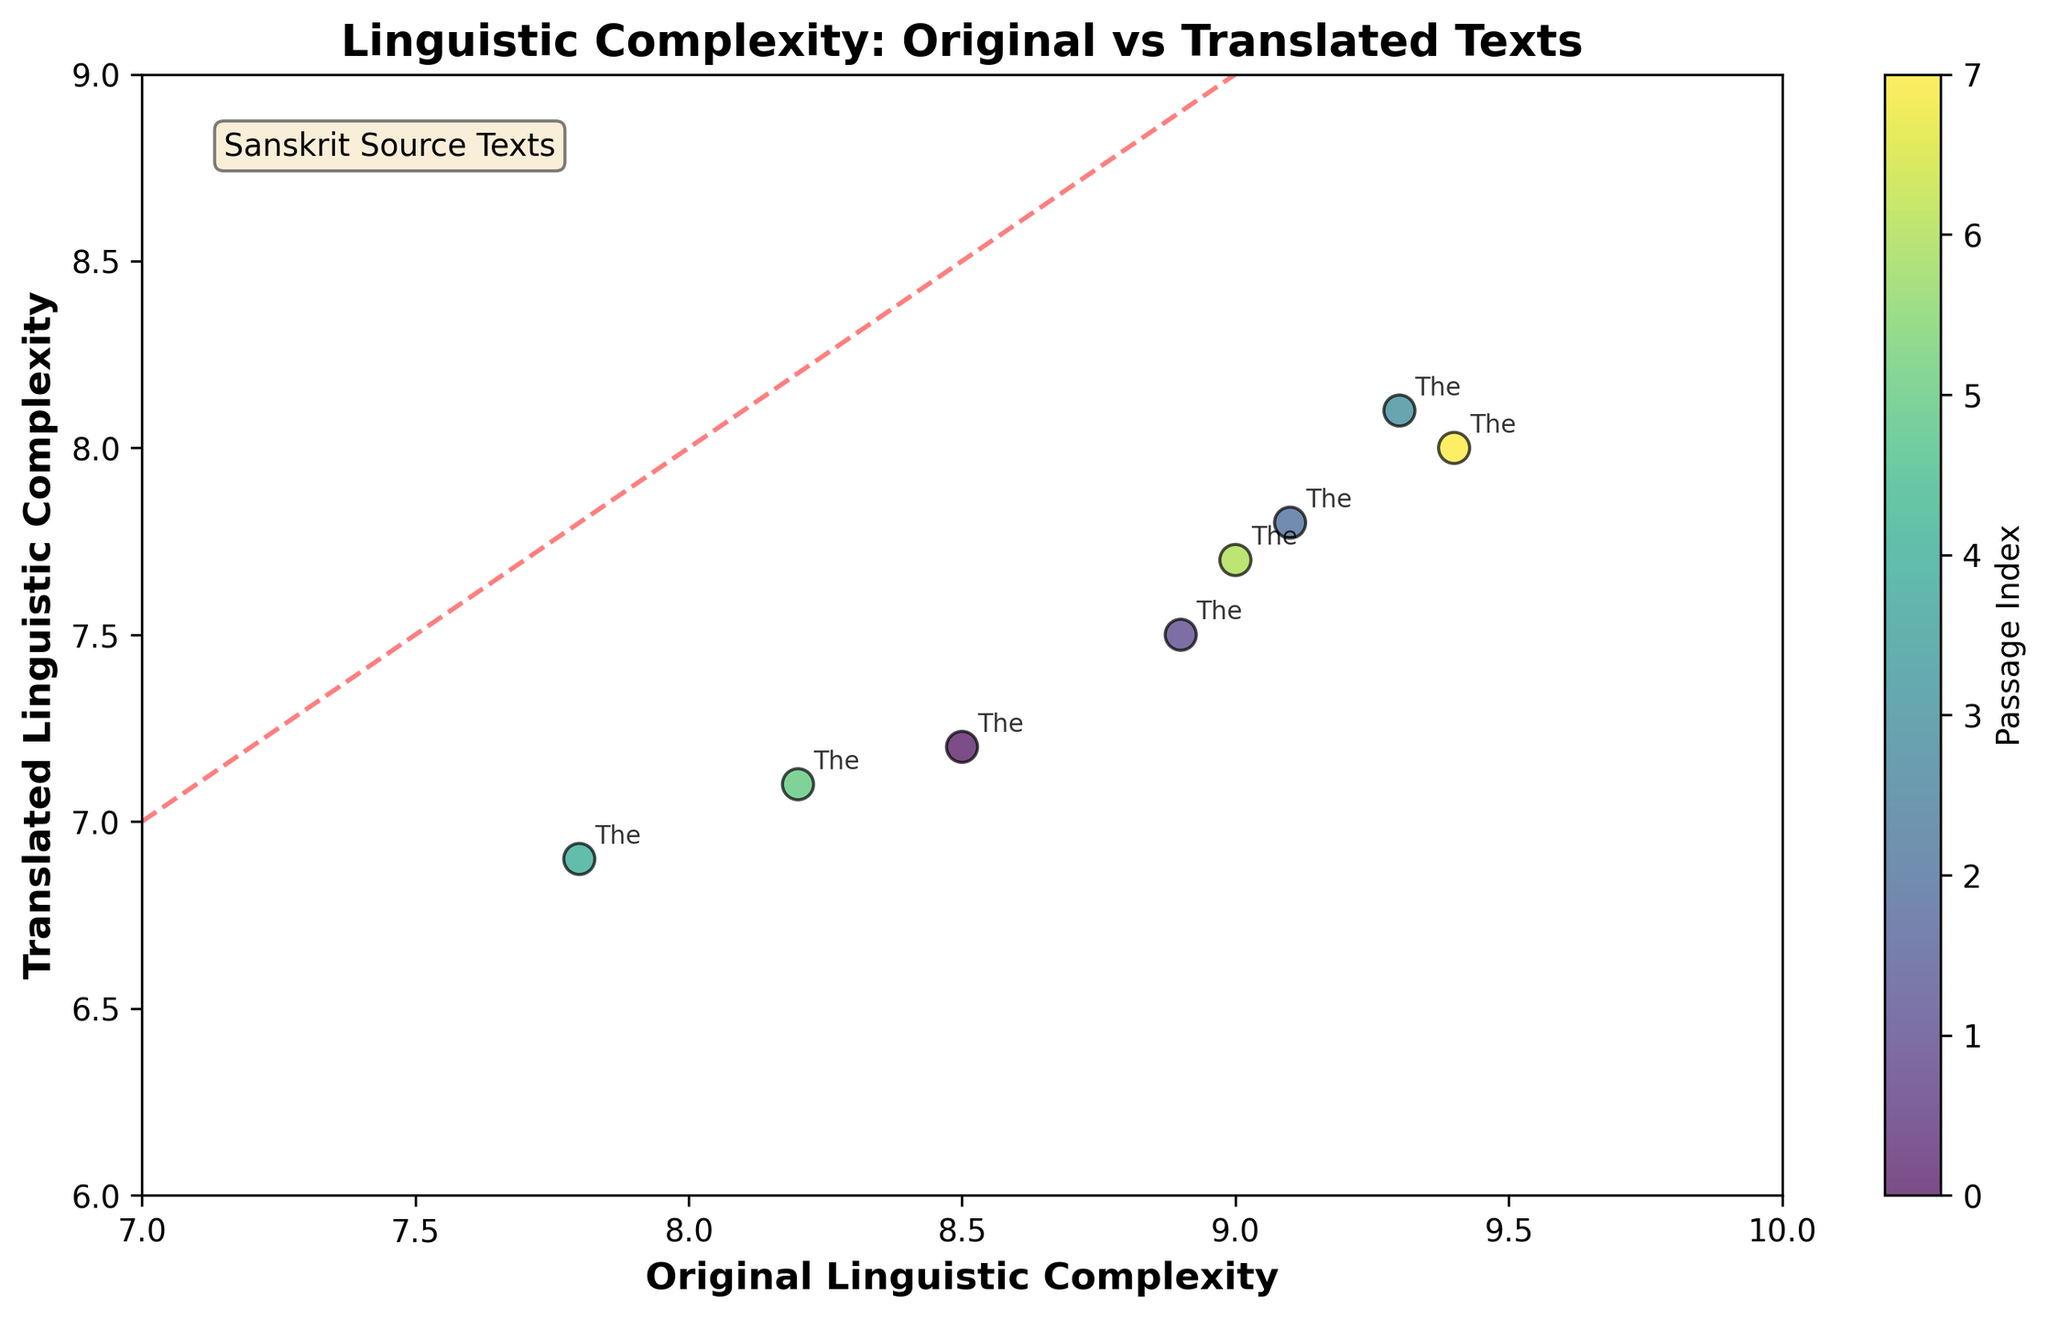What is the title of the plot? The title is located at the top of the plot and reads "Linguistic Complexity: Original vs Translated Texts".
Answer: Linguistic Complexity: Original vs Translated Texts What does the x-axis represent? The label on the x-axis shows "Original Linguistic Complexity", indicating it displays linguistic complexity scores of the original texts.
Answer: Original Linguistic Complexity What feature is represented by the colors of the scatter plot? The colorbar labeled "Passage Index" indicates that different colors correspond to different passages from the texts.
Answer: Passage Index How many data points are plotted in total? There are 8 different colors on the plot, representing each passage, and hence, there are 8 data points in total.
Answer: 8 What is the range of linguistic complexities for the translated texts? The smallest translated complexity is 6.9 and the largest is 8.1, which you can observe on the y-axis.
Answer: 6.9 to 8.1 Which passage has the highest original linguistic complexity? The data point labeled “Rigveda” is furthest to the right, indicating the highest original linguistic complexity of 9.4.
Answer: Rigveda Which passage has the smallest gap between original and translated complexities? The gap can be calculated for each data point and the smallest gap is observed for "Mundaka" (Original: 9.3, Translated: 8.1, Gap: 1.2).
Answer: Mundaka What does the diagonal red dashed line in the plot signify? The diagonal line represents where original and translated complexities are equal, cutting from (6,6) to (10,10). Data points above the line have higher translated than original complexities, while those below it have higher original complexities.
Answer: Equality of original and translated complexities How many passages have a translated complexity above 7.5? Count the data points on the scatter plot above y=7.5; the Bhagavad Gita Chapters 2 and 4, the Upanishads Isha, the Upanishads Mundaka, and the Bhagavad Gita Chapter 18 meet this criterion (5 passages).
Answer: 5 Is there an overall trend between original and translated complexities? Observing the scatter plot, generally, as original complexity increases, translated complexity also increases, though it tends to be somewhat lower than the original.
Answer: Positive correlation, but translated is lower 